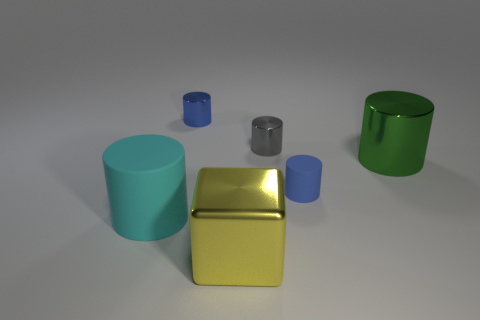Subtract all blue metal cylinders. How many cylinders are left? 4 Subtract all green cylinders. How many cylinders are left? 4 Subtract all cyan cubes. How many blue cylinders are left? 2 Add 1 blue matte cylinders. How many objects exist? 7 Subtract all green cylinders. Subtract all red cubes. How many cylinders are left? 4 Add 3 big cubes. How many big cubes exist? 4 Subtract 1 gray cylinders. How many objects are left? 5 Subtract all cylinders. How many objects are left? 1 Subtract all large green matte cylinders. Subtract all small objects. How many objects are left? 3 Add 4 cyan matte objects. How many cyan matte objects are left? 5 